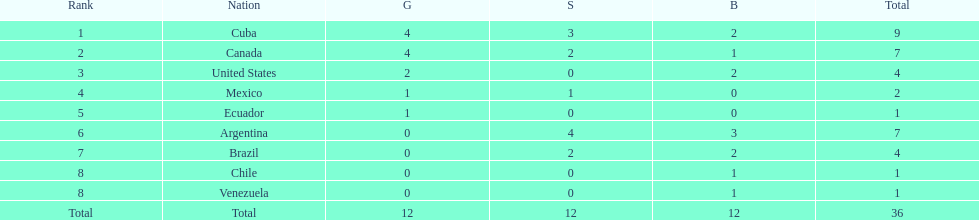Who is ranked #1? Cuba. 